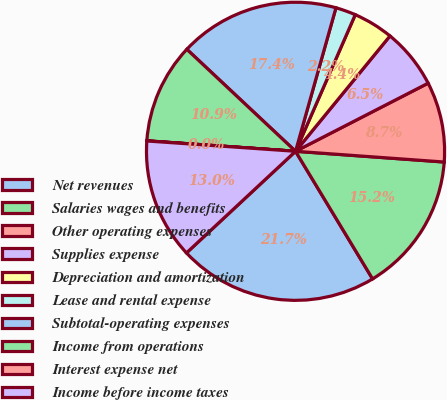Convert chart. <chart><loc_0><loc_0><loc_500><loc_500><pie_chart><fcel>Net revenues<fcel>Salaries wages and benefits<fcel>Other operating expenses<fcel>Supplies expense<fcel>Depreciation and amortization<fcel>Lease and rental expense<fcel>Subtotal-operating expenses<fcel>Income from operations<fcel>Interest expense net<fcel>Income before income taxes<nl><fcel>21.71%<fcel>15.21%<fcel>8.7%<fcel>6.53%<fcel>4.36%<fcel>2.19%<fcel>17.38%<fcel>10.87%<fcel>0.02%<fcel>13.04%<nl></chart> 